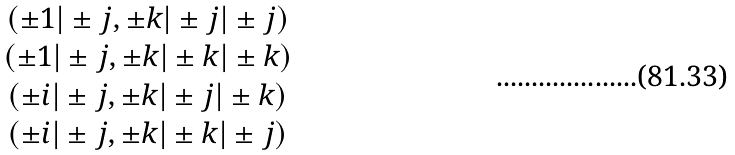Convert formula to latex. <formula><loc_0><loc_0><loc_500><loc_500>\begin{array} { c } ( \pm 1 | \pm j , \pm k | \pm j | \pm j ) \\ ( \pm 1 | \pm j , \pm k | \pm k | \pm k ) \\ ( \pm i | \pm j , \pm k | \pm j | \pm k ) \\ ( \pm i | \pm j , \pm k | \pm k | \pm j ) \end{array}</formula> 